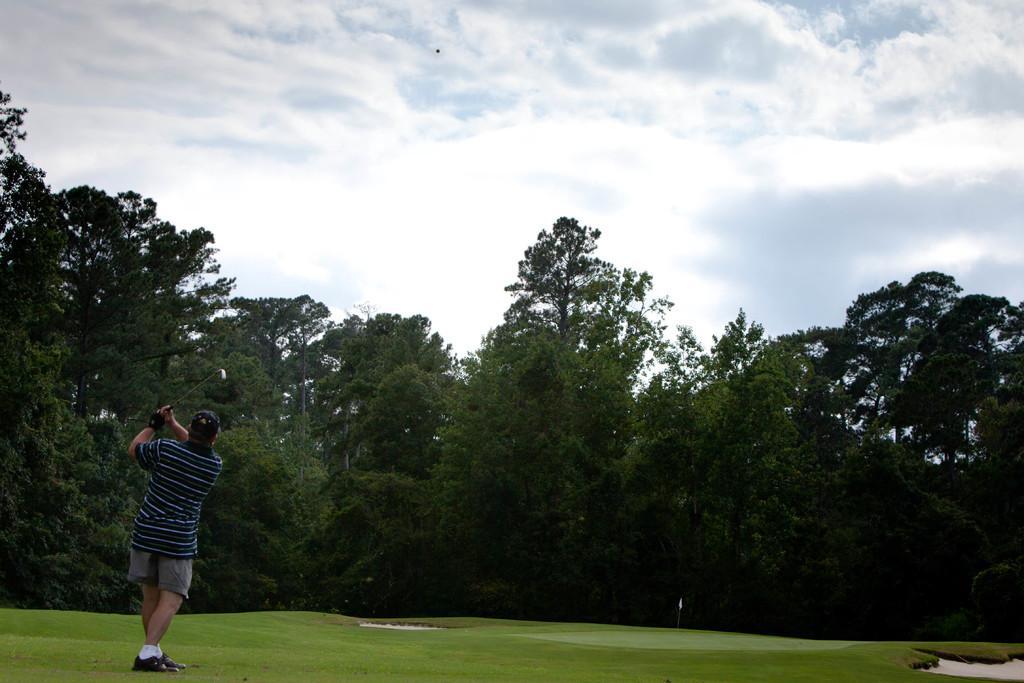Describe this image in one or two sentences. In this image I can see a person wearing hat, t shirt, short and footwear is standing and holding a golf stick in his hand. I can see a ball over here. In the background I can see few trees, the golf court, a white colored flag and the sky. 